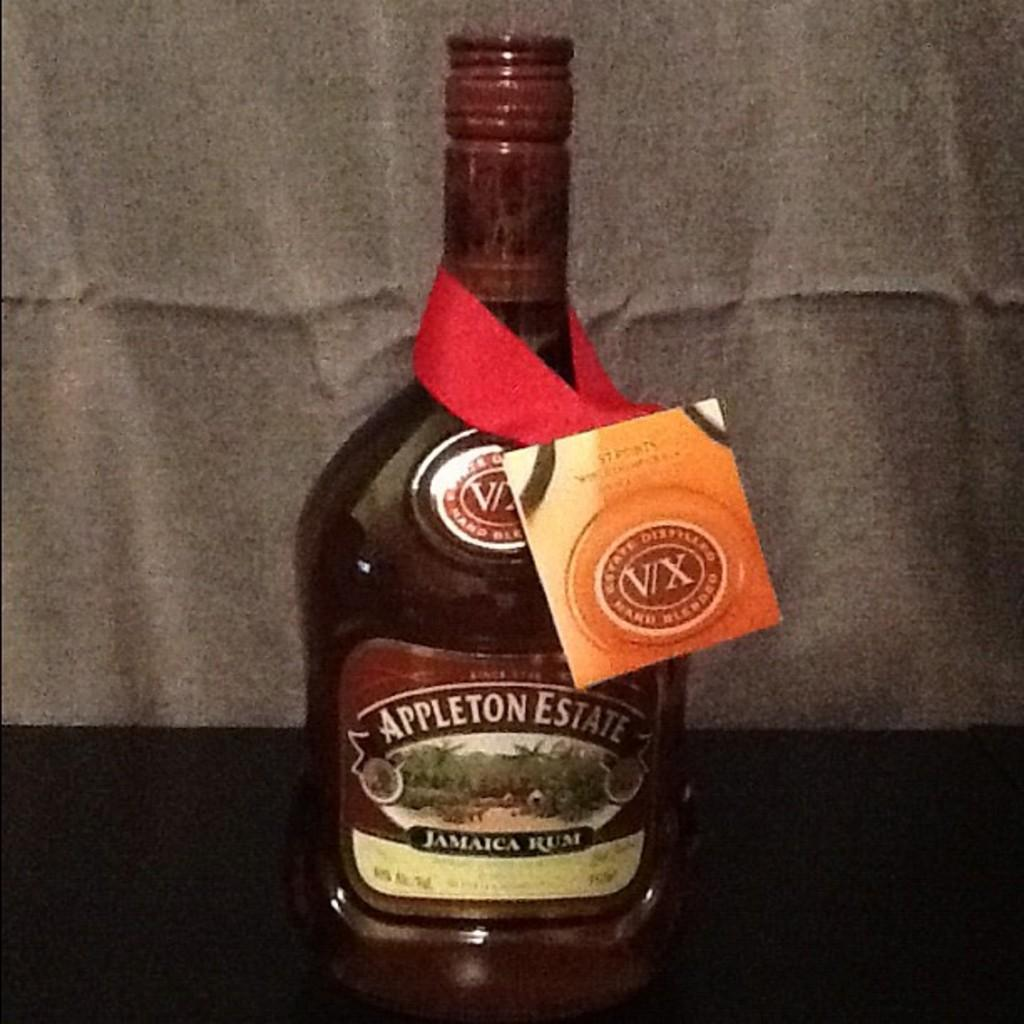<image>
Provide a brief description of the given image. The alcoholic beverage was made by the Appleton Estate. 